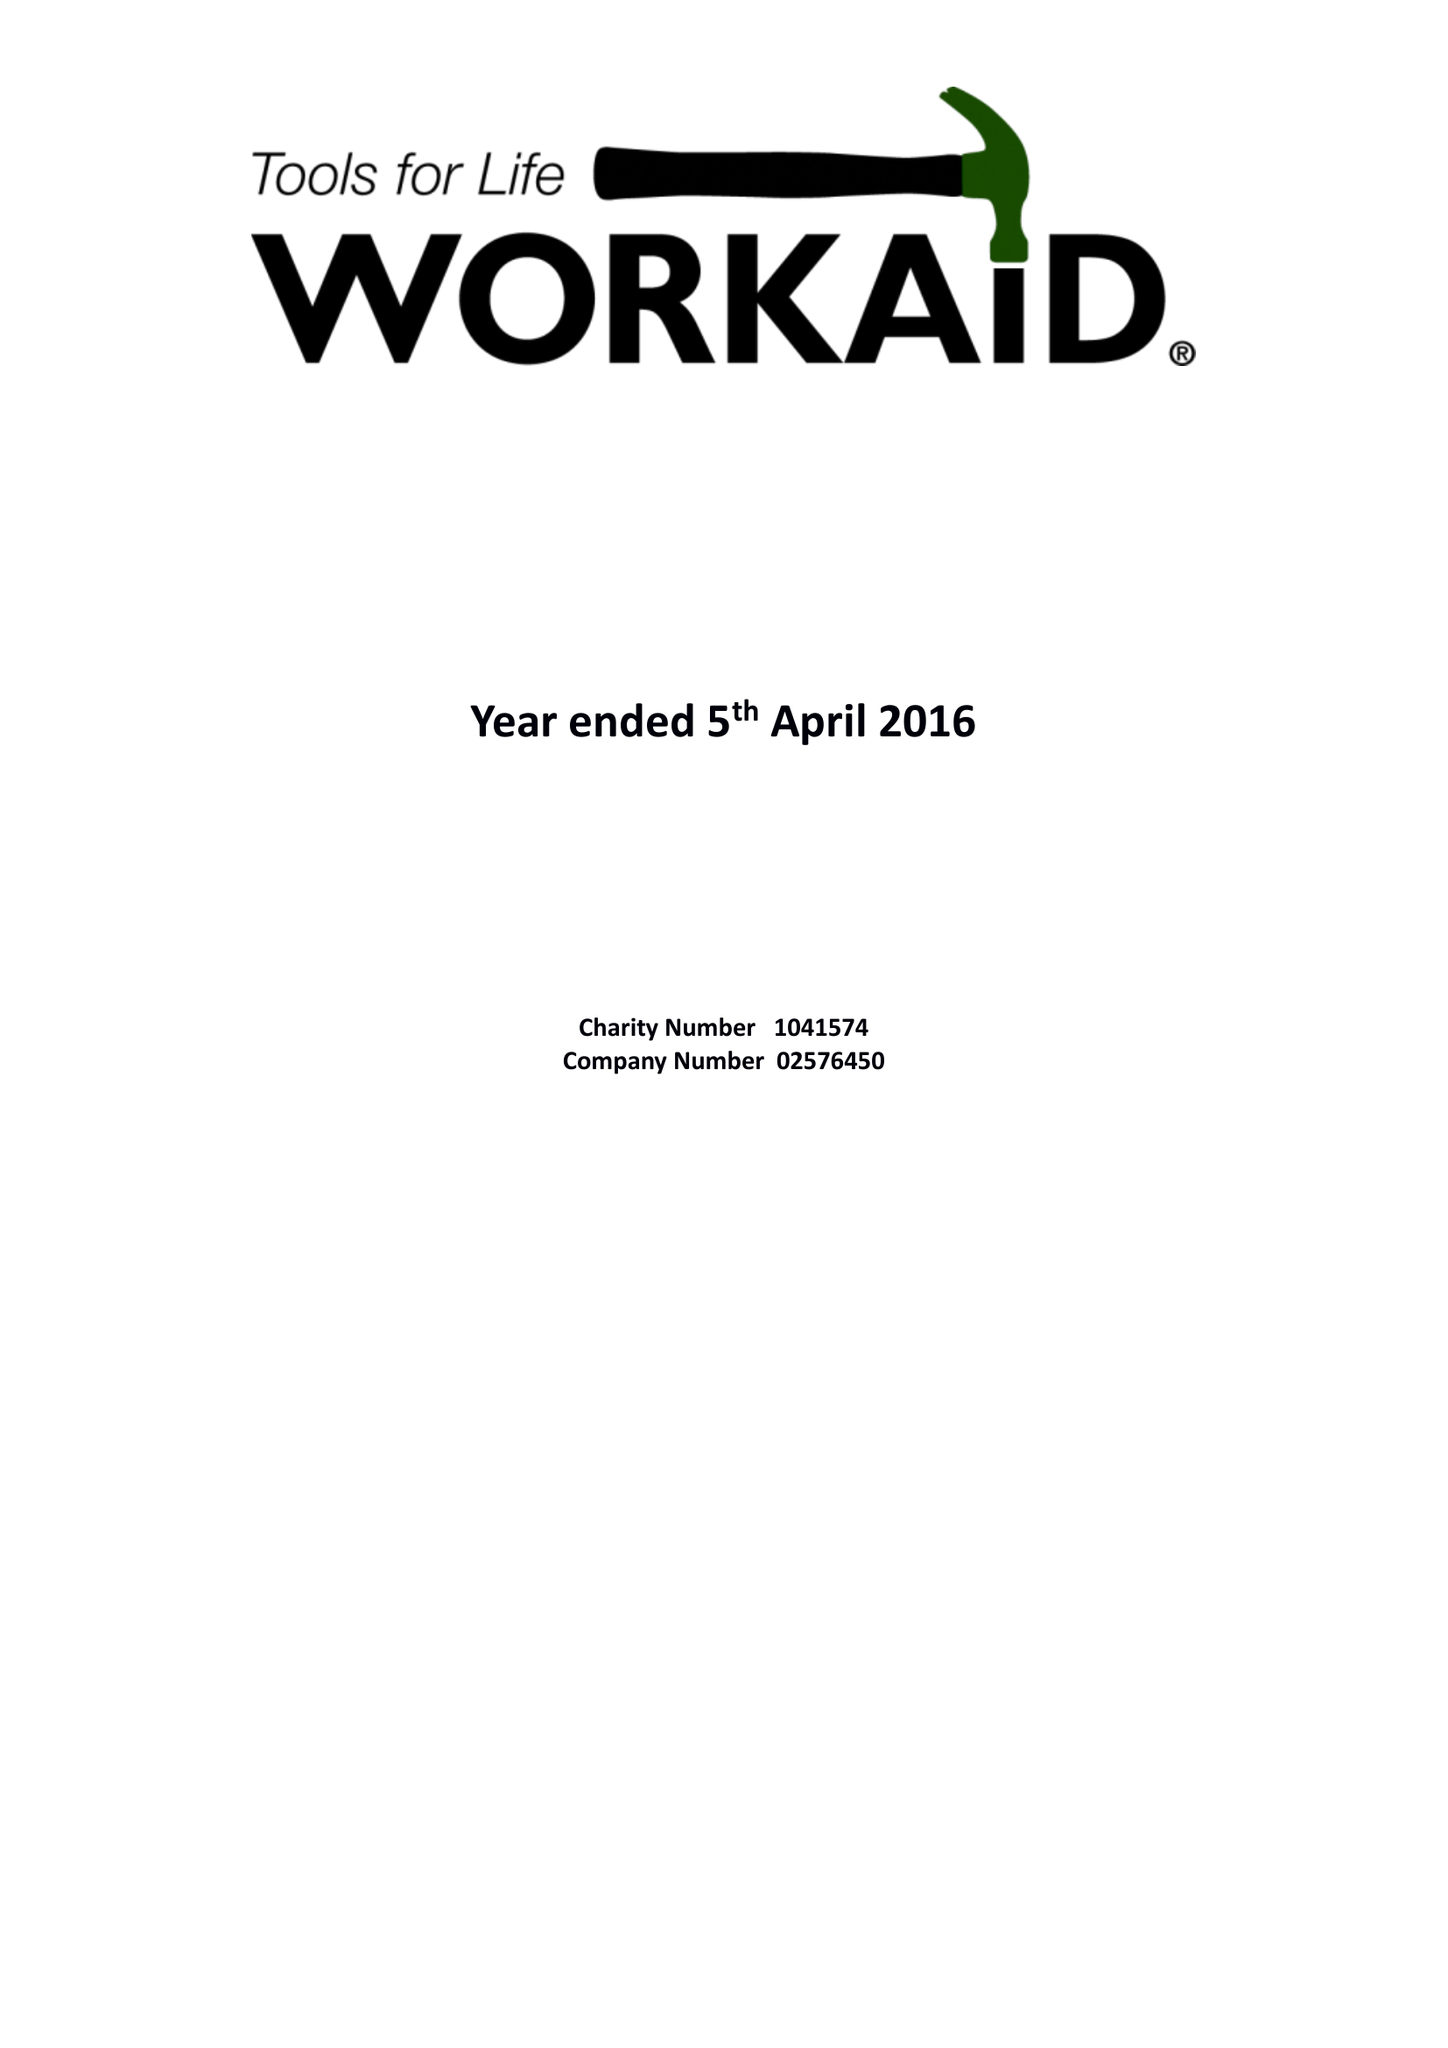What is the value for the income_annually_in_british_pounds?
Answer the question using a single word or phrase. 239033.00 